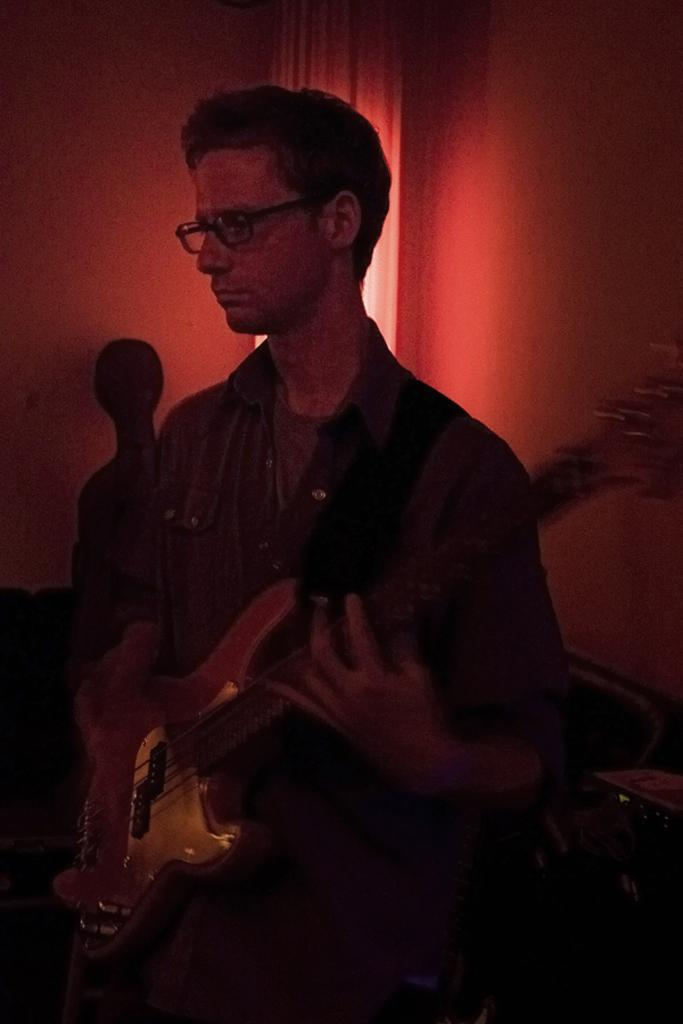What is the main subject of the image? The main subject of the image is a man. What is the man doing in the image? The man is standing and may be playing the guitar. What object is the man holding in the image? The man is holding a guitar. What can be seen on the man's face in the image? The man is wearing spectacles. What colors are present in the background of the image? The background of the image is white and red. How many horses can be seen in the image? There are no horses present in the image. What type of suggestion is the man giving in the image? The image does not provide any information about the man giving a suggestion. 